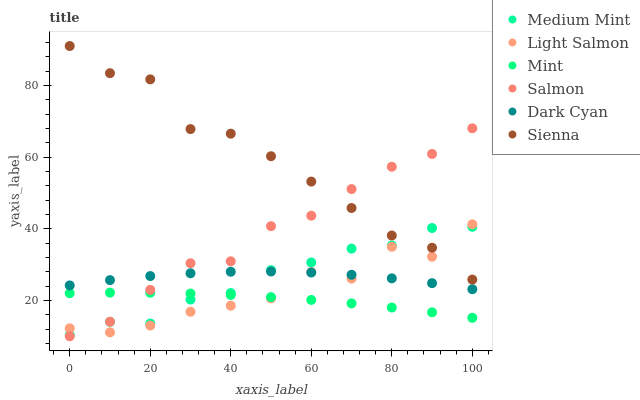Does Mint have the minimum area under the curve?
Answer yes or no. Yes. Does Sienna have the maximum area under the curve?
Answer yes or no. Yes. Does Light Salmon have the minimum area under the curve?
Answer yes or no. No. Does Light Salmon have the maximum area under the curve?
Answer yes or no. No. Is Mint the smoothest?
Answer yes or no. Yes. Is Light Salmon the roughest?
Answer yes or no. Yes. Is Salmon the smoothest?
Answer yes or no. No. Is Salmon the roughest?
Answer yes or no. No. Does Salmon have the lowest value?
Answer yes or no. Yes. Does Light Salmon have the lowest value?
Answer yes or no. No. Does Sienna have the highest value?
Answer yes or no. Yes. Does Light Salmon have the highest value?
Answer yes or no. No. Is Dark Cyan less than Sienna?
Answer yes or no. Yes. Is Sienna greater than Dark Cyan?
Answer yes or no. Yes. Does Salmon intersect Sienna?
Answer yes or no. Yes. Is Salmon less than Sienna?
Answer yes or no. No. Is Salmon greater than Sienna?
Answer yes or no. No. Does Dark Cyan intersect Sienna?
Answer yes or no. No. 